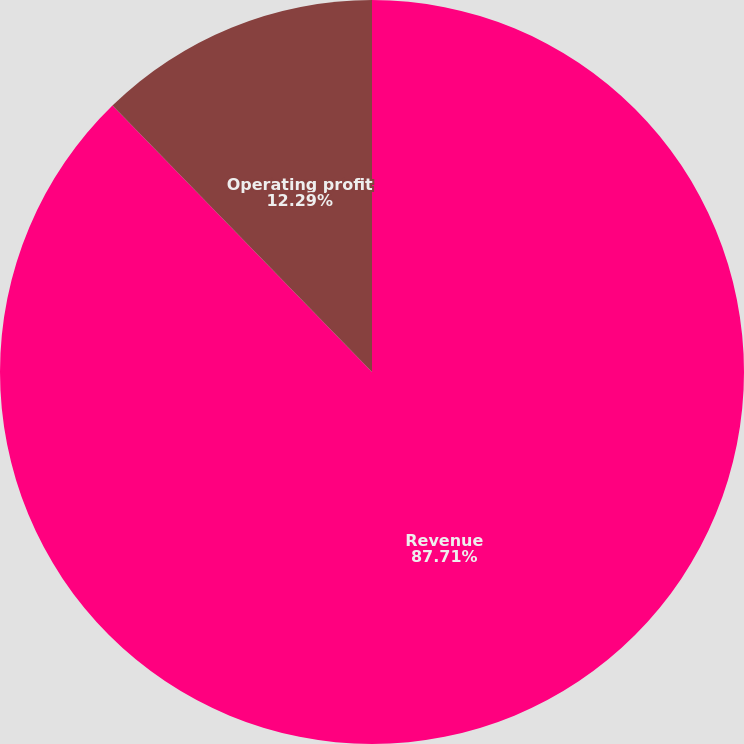Convert chart to OTSL. <chart><loc_0><loc_0><loc_500><loc_500><pie_chart><fcel>Revenue<fcel>Operating profit<nl><fcel>87.71%<fcel>12.29%<nl></chart> 